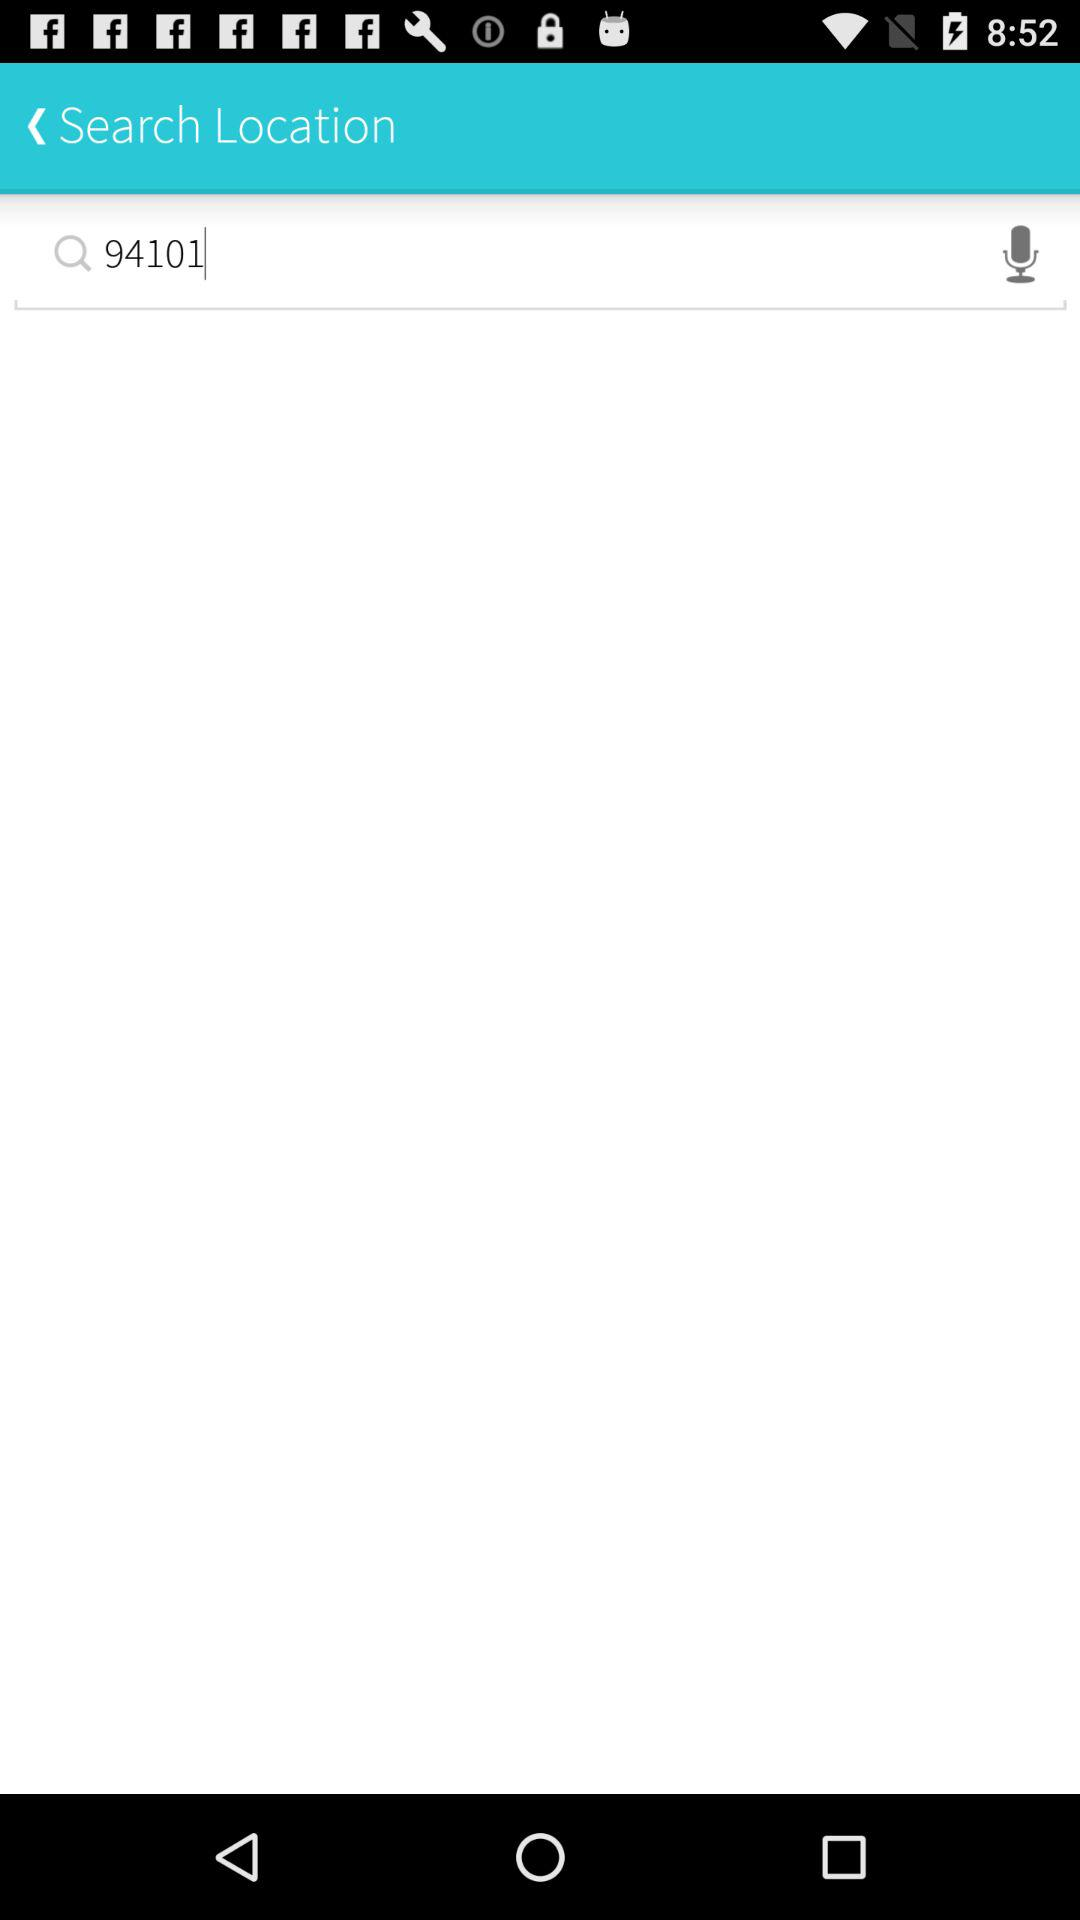What is the value in the search bar? The value in the search bar is 94101. 